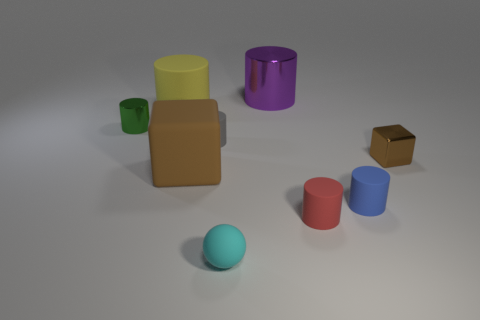What is the material of the other block that is the same color as the tiny metal cube?
Offer a very short reply. Rubber. Do the small green object and the purple cylinder have the same material?
Make the answer very short. Yes. What shape is the green metallic object that is the same size as the cyan rubber thing?
Provide a short and direct response. Cylinder. Are there more gray spheres than small red objects?
Provide a succinct answer. No. There is a object that is behind the small green metallic cylinder and left of the large brown rubber cube; what material is it made of?
Make the answer very short. Rubber. What number of other things are there of the same material as the cyan object
Offer a very short reply. 5. What number of tiny matte things are the same color as the big block?
Provide a short and direct response. 0. There is a shiny thing that is in front of the shiny thing left of the brown object on the left side of the blue cylinder; what size is it?
Ensure brevity in your answer.  Small. How many metal objects are tiny cubes or small green cylinders?
Provide a short and direct response. 2. There is a big brown matte object; is its shape the same as the tiny shiny object that is on the right side of the tiny cyan thing?
Keep it short and to the point. Yes. 